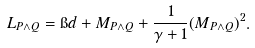Convert formula to latex. <formula><loc_0><loc_0><loc_500><loc_500>L _ { P \wedge Q } = \i d + M _ { P \wedge Q } + \frac { 1 } { \gamma + 1 } ( M _ { P \wedge Q } ) ^ { 2 } .</formula> 